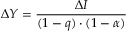Convert formula to latex. <formula><loc_0><loc_0><loc_500><loc_500>\Delta Y = { \frac { \Delta I } { ( 1 - q ) \cdot ( 1 - \alpha ) } } \,</formula> 